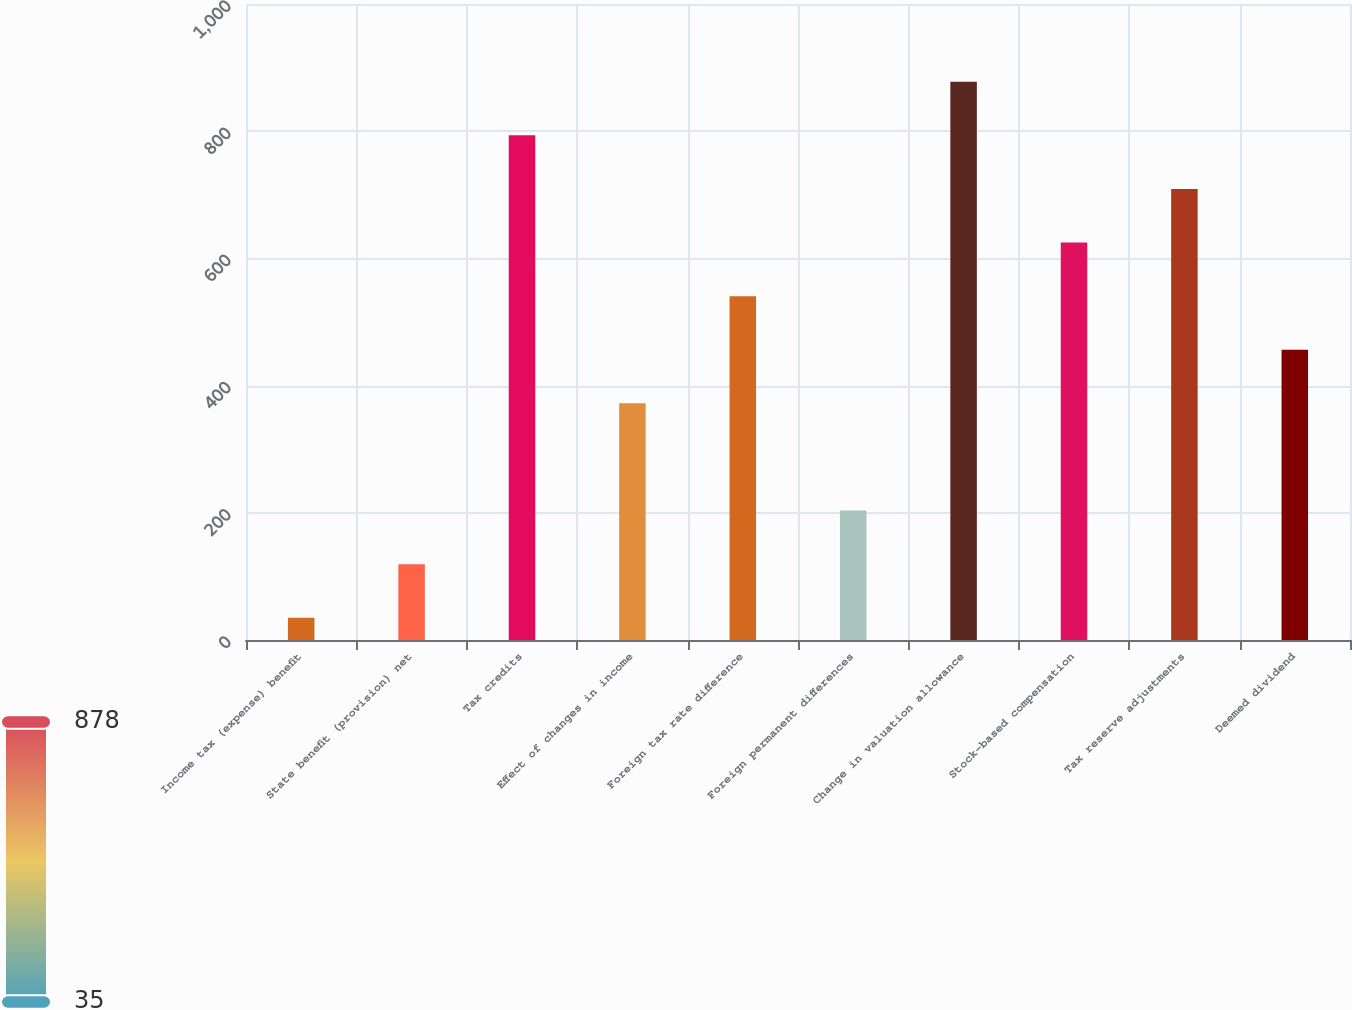<chart> <loc_0><loc_0><loc_500><loc_500><bar_chart><fcel>Income tax (expense) benefit<fcel>State benefit (provision) net<fcel>Tax credits<fcel>Effect of changes in income<fcel>Foreign tax rate difference<fcel>Foreign permanent differences<fcel>Change in valuation allowance<fcel>Stock-based compensation<fcel>Tax reserve adjustments<fcel>Deemed dividend<nl><fcel>35<fcel>119.28<fcel>793.52<fcel>372.12<fcel>540.68<fcel>203.56<fcel>877.84<fcel>624.96<fcel>709.24<fcel>456.4<nl></chart> 